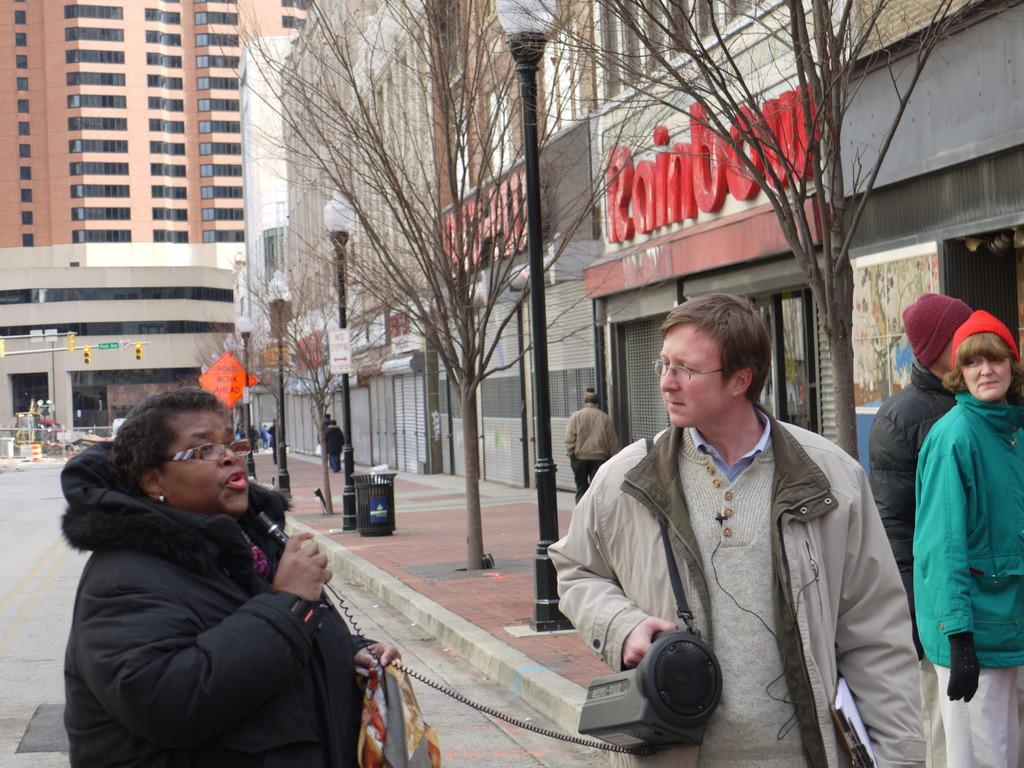What type of structures can be seen in the image? There are buildings in the image. What type of lighting is present in the image? There are street lamps in the image. What type of vegetation is present in the image? There are trees in the image. What type of object is present for waste disposal? There is a dustbin in the image. What type of barrier is present in the image? There is a fence in the image. Are there any people visible in the image? A: Yes, there are people in the image. What type of traffic control devices can be seen in the background of the image? There are traffic signals in the background of the image. What type of wood is used to make the faces of the people in the image? There are no faces made of wood in the image; the people are real individuals. What type of tax is being collected from the buildings in the image? There is no indication of any tax being collected in the image; it simply shows buildings, street lamps, trees, a dustbin, a fence, people, and traffic signals. 